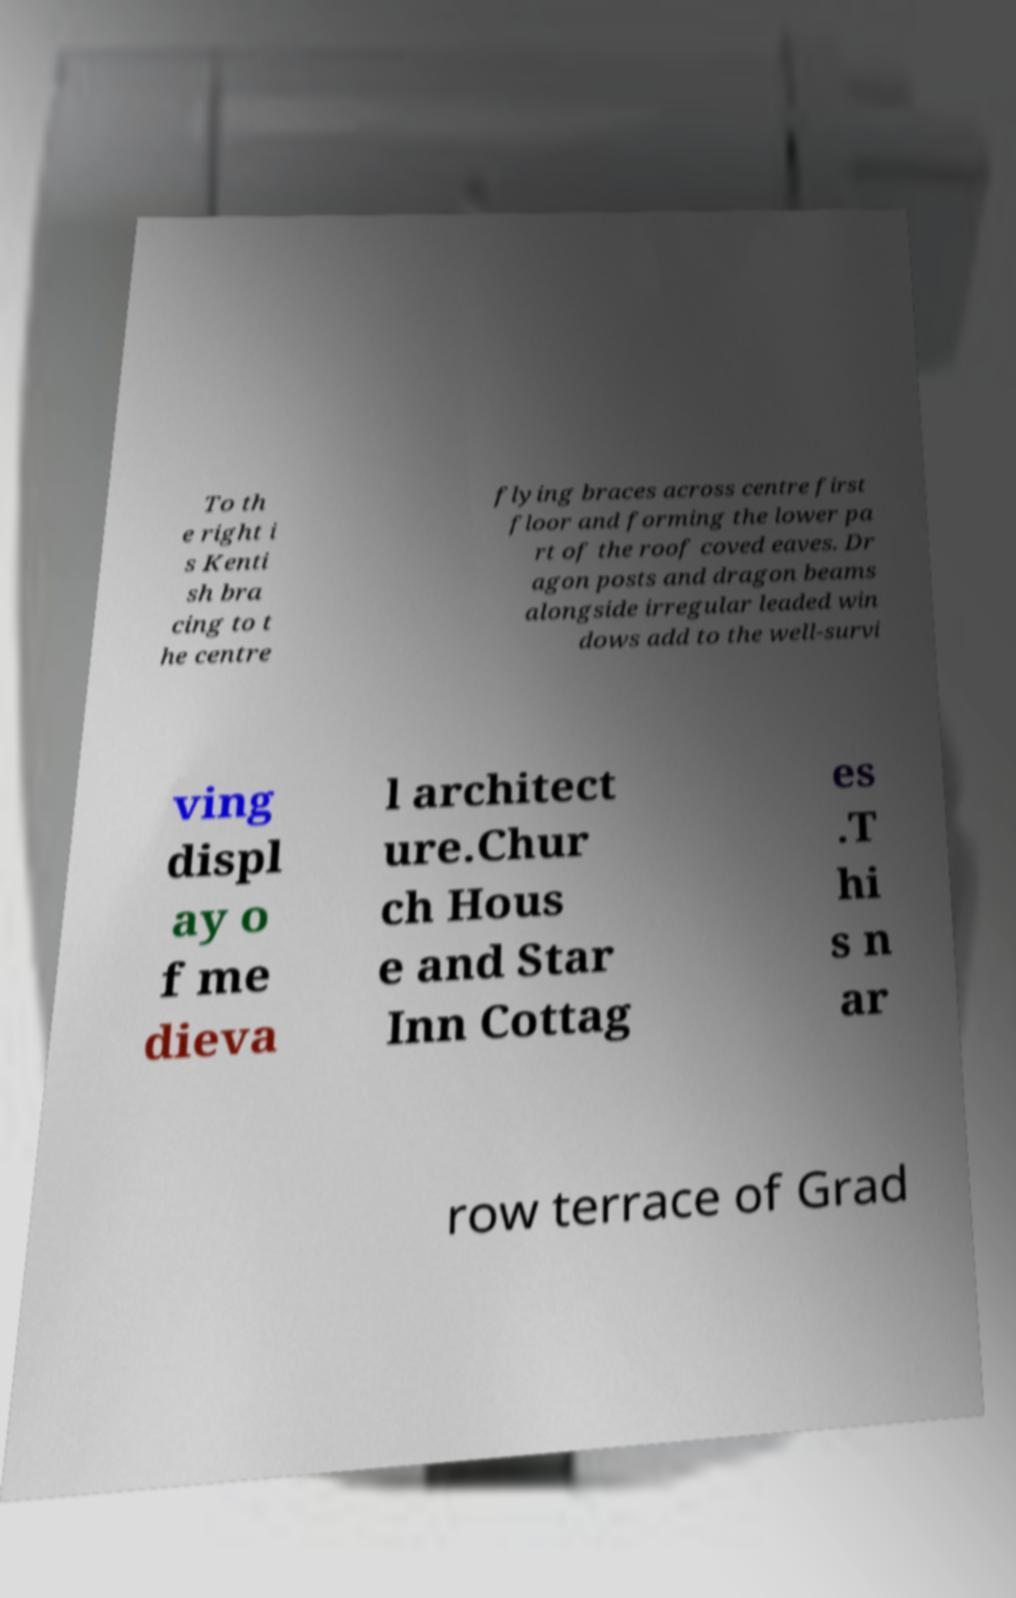For documentation purposes, I need the text within this image transcribed. Could you provide that? To th e right i s Kenti sh bra cing to t he centre flying braces across centre first floor and forming the lower pa rt of the roof coved eaves. Dr agon posts and dragon beams alongside irregular leaded win dows add to the well-survi ving displ ay o f me dieva l architect ure.Chur ch Hous e and Star Inn Cottag es .T hi s n ar row terrace of Grad 